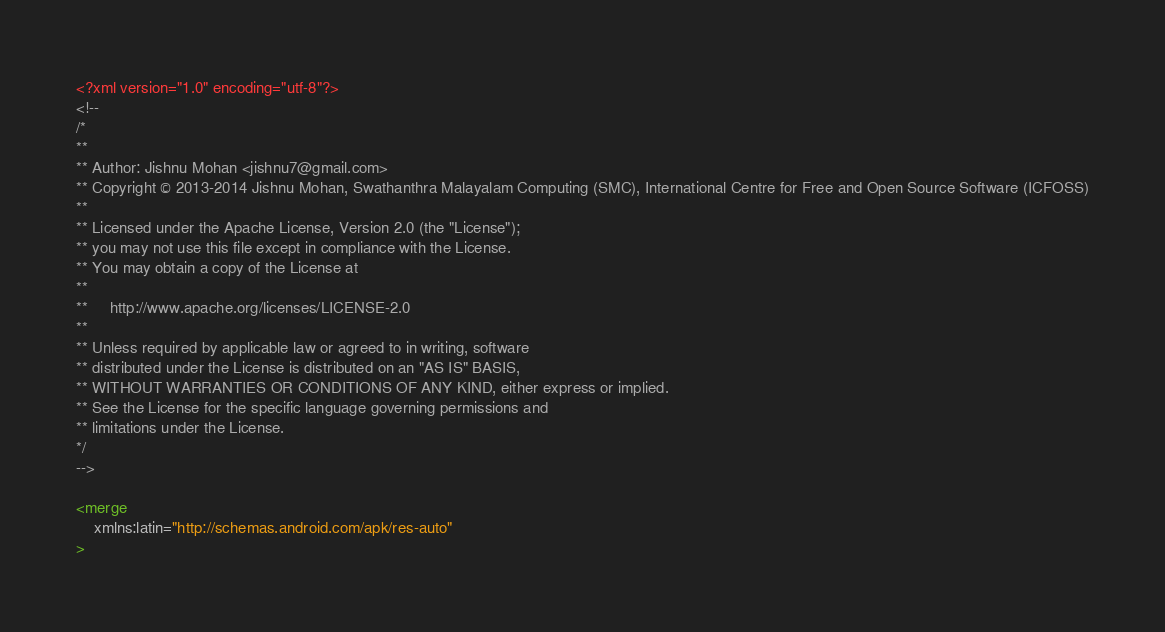<code> <loc_0><loc_0><loc_500><loc_500><_XML_><?xml version="1.0" encoding="utf-8"?>
<!--
/*
**
** Author: Jishnu Mohan <jishnu7@gmail.com>
** Copyright © 2013-2014 Jishnu Mohan, Swathanthra Malayalam Computing (SMC), International Centre for Free and Open Source Software (ICFOSS)
**
** Licensed under the Apache License, Version 2.0 (the "License");
** you may not use this file except in compliance with the License.
** You may obtain a copy of the License at
**
**     http://www.apache.org/licenses/LICENSE-2.0
**
** Unless required by applicable law or agreed to in writing, software
** distributed under the License is distributed on an "AS IS" BASIS,
** WITHOUT WARRANTIES OR CONDITIONS OF ANY KIND, either express or implied.
** See the License for the specific language governing permissions and
** limitations under the License.
*/
-->

<merge
    xmlns:latin="http://schemas.android.com/apk/res-auto"
></code> 